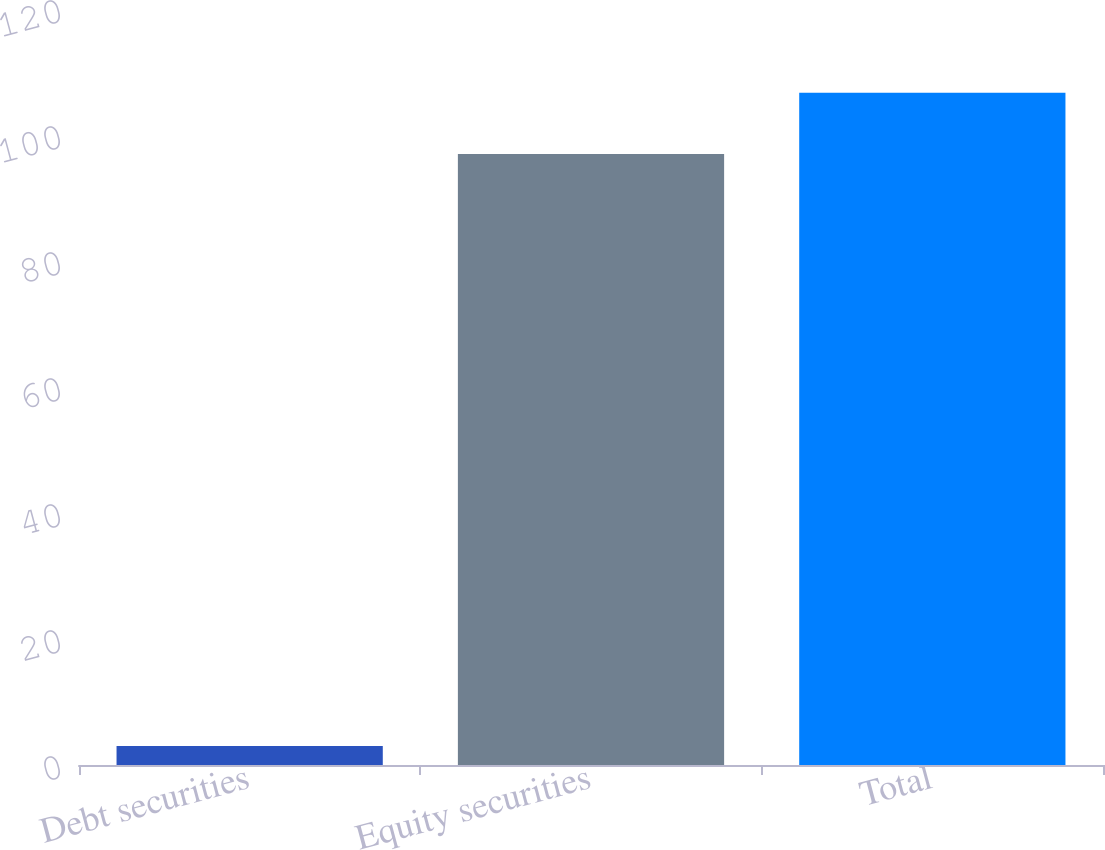Convert chart. <chart><loc_0><loc_0><loc_500><loc_500><bar_chart><fcel>Debt securities<fcel>Equity securities<fcel>Total<nl><fcel>3<fcel>97<fcel>106.7<nl></chart> 